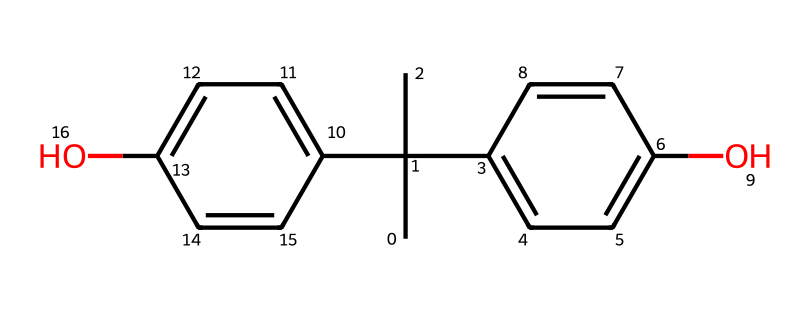What is the primary functional group present in this chemical? The chemical structure shows two hydroxyl (-OH) groups, indicating that the primary functional group present is alcohol, which is characteristic of phenols.
Answer: hydroxyl How many aromatic rings are present in this compound? The SMILES representation indicates two distinct cycles that contain alternating double bonds, which correspond to two aromatic rings in the structure.
Answer: two What type of chemical is this compound classified as? Given the presence of hydroxyl groups attached to aromatic rings, this compound is classified as a phenolic compound, specifically a diphenol due to two phenol structures.
Answer: phenol What is the total number of carbon atoms in the compound? By analyzing the SMILES, we can count the carbon atoms. There are a total of ten carbon atoms in the structure, which are part of both the aromatic rings and the branched groups.
Answer: ten How many hydrogen atoms are likely present in this compound? Each carbon generally bonds with hydrogen atoms unless it is bonded to other functional groups. From the structure, we can deduce and calculate that there are a total of ten hydrogen atoms present when considering the bonded hydroxyl groups and the carbon structure.
Answer: ten Which characteristic of this compound contributes to its use in camouflage paint? The presence of multiple hydroxyl groups enhances the adhesive properties and allows pigments to disperse better, which contributes to the effectiveness of this compound in paint formulations, particularly in camouflage.
Answer: adhesive properties 